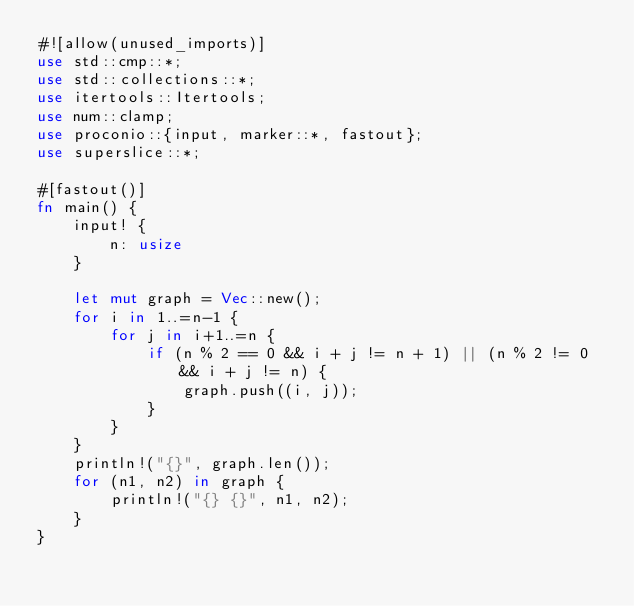<code> <loc_0><loc_0><loc_500><loc_500><_Rust_>#![allow(unused_imports)]
use std::cmp::*;
use std::collections::*;
use itertools::Itertools;
use num::clamp;
use proconio::{input, marker::*, fastout};
use superslice::*;

#[fastout()]
fn main() {
    input! {
        n: usize
    }

    let mut graph = Vec::new();
    for i in 1..=n-1 {
        for j in i+1..=n {
            if (n % 2 == 0 && i + j != n + 1) || (n % 2 != 0 && i + j != n) {
                graph.push((i, j));
            }
        }
    }
    println!("{}", graph.len());
    for (n1, n2) in graph {
        println!("{} {}", n1, n2);
    }
}
</code> 